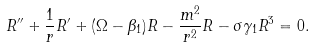<formula> <loc_0><loc_0><loc_500><loc_500>R ^ { \prime \prime } + \frac { 1 } { r } R ^ { \prime } + ( \Omega - \beta _ { 1 } ) R - \frac { m ^ { 2 } } { r ^ { 2 } } R - \sigma \gamma _ { 1 } R ^ { 3 } = 0 .</formula> 